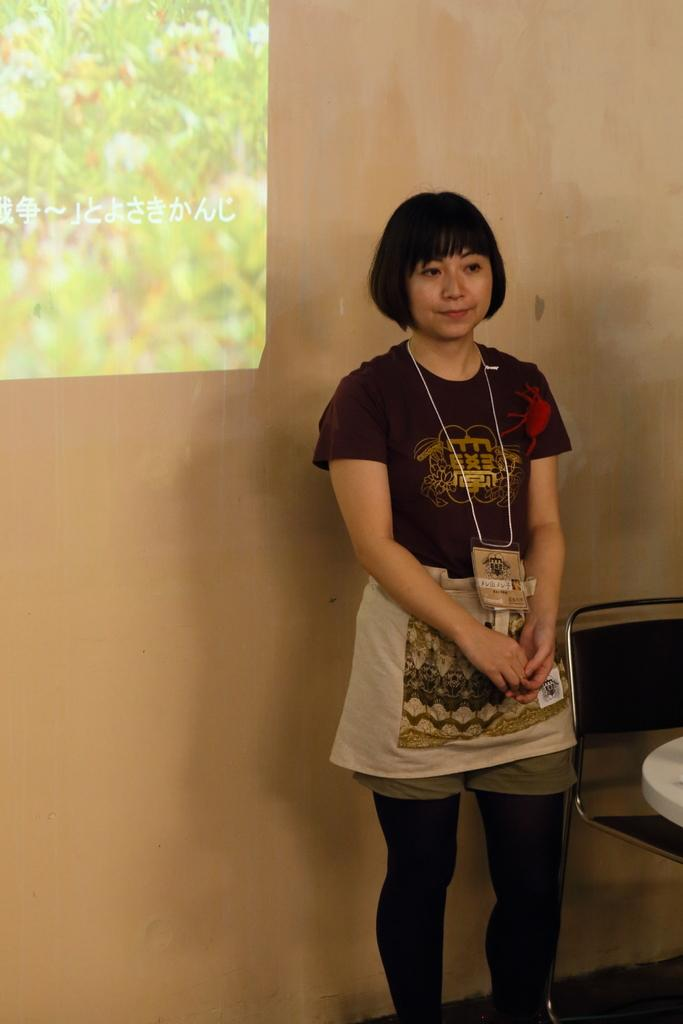What is the main subject of the picture? There is a woman standing in the center of the picture. What can be seen on the right side of the image? There is a chair on the right side of the image. What is on the chair? There is an object on the chair. What is on the left side of the image? There is a projector screen on the left side of the image. What type of wren can be seen singing on the projector screen in the image? There is no wren present in the image, and the projector screen does not depict any birds or animals. 